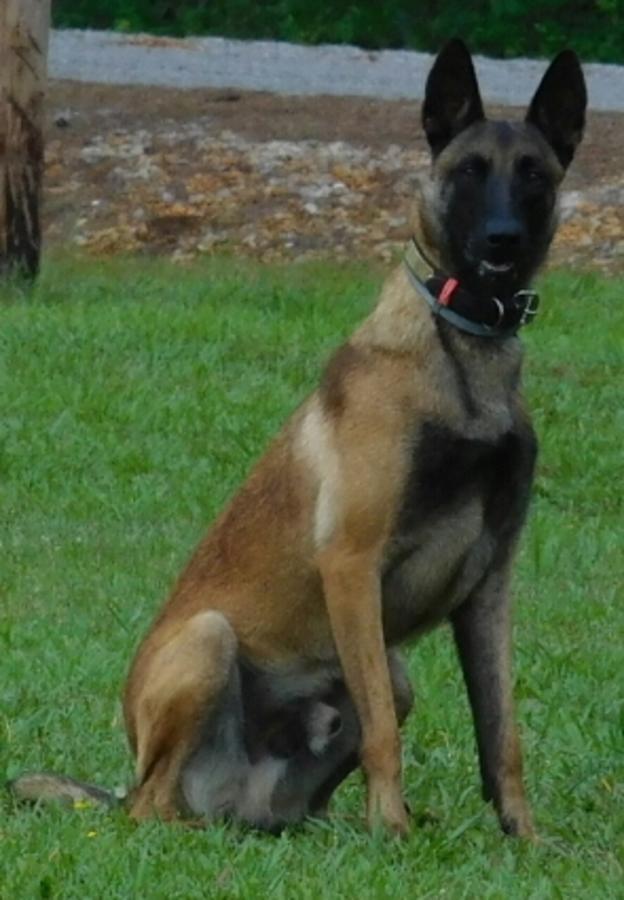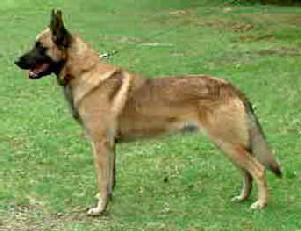The first image is the image on the left, the second image is the image on the right. Evaluate the accuracy of this statement regarding the images: "One of the dogs is sitting down & looking towards the camera.". Is it true? Answer yes or no. Yes. The first image is the image on the left, the second image is the image on the right. Examine the images to the left and right. Is the description "At least one dog has a leash attached, and at least one dog has an open, non-snarling mouth." accurate? Answer yes or no. Yes. 